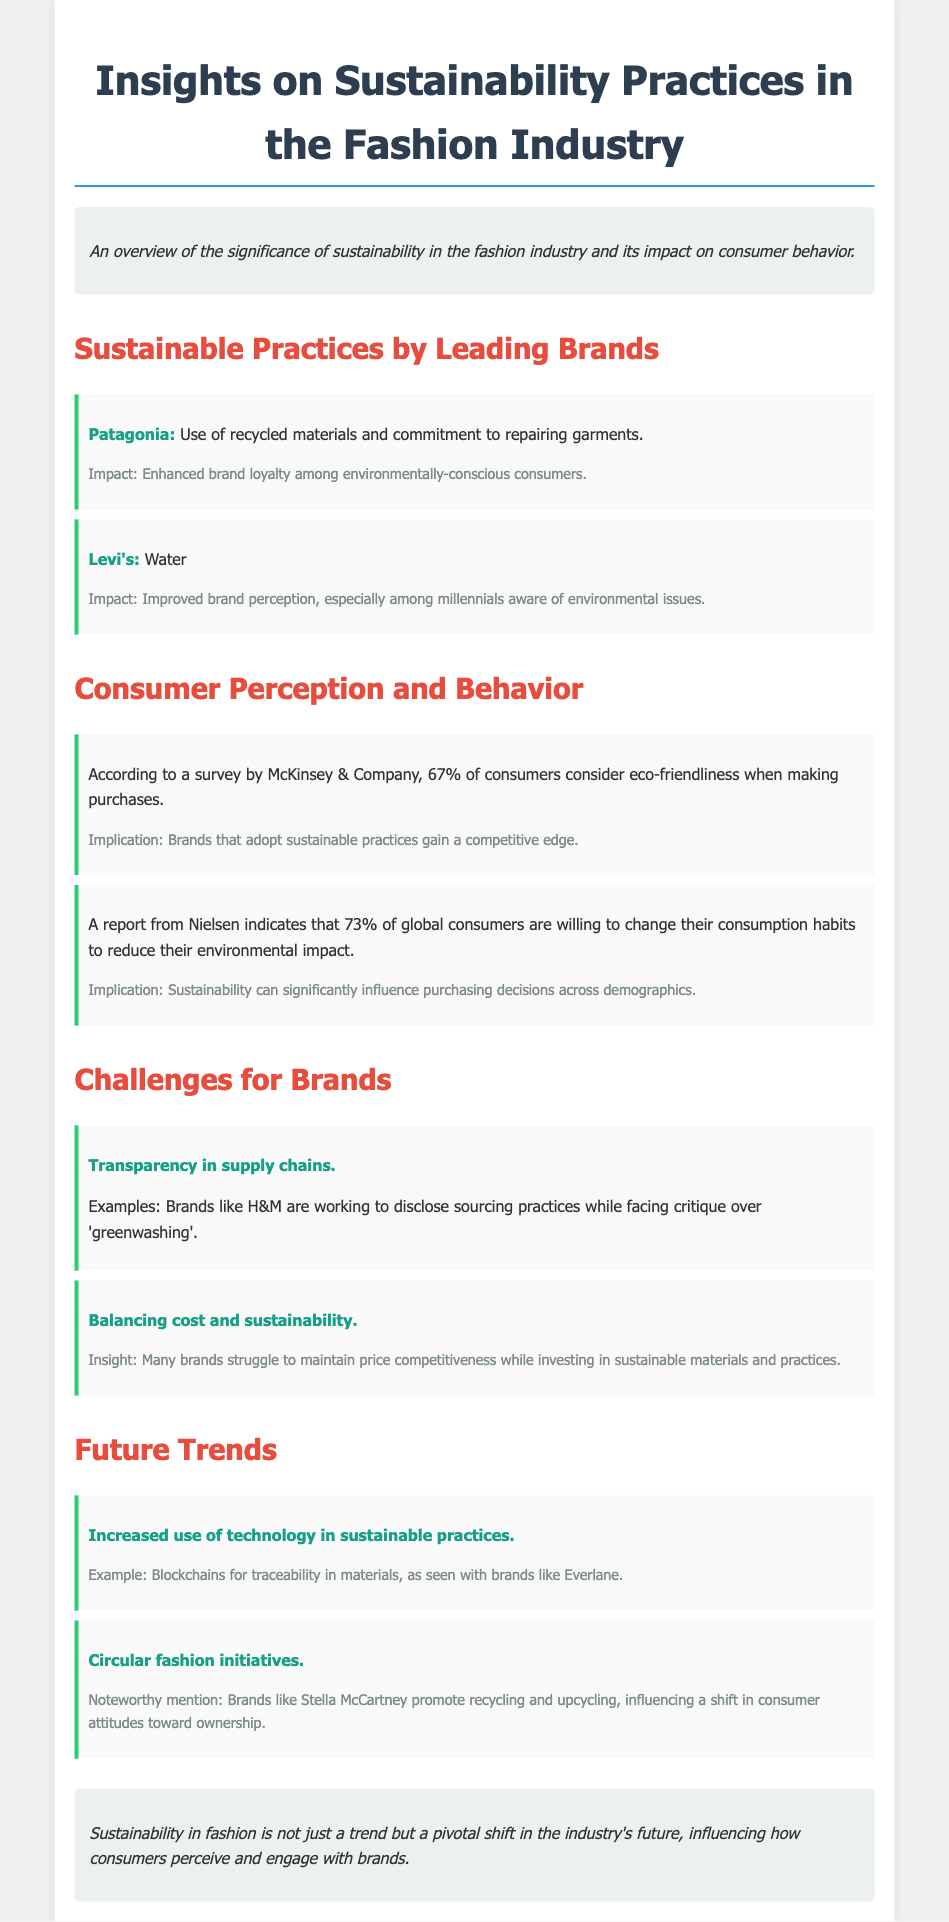What sustainable practice does Patagonia implement? Patagonia uses recycled materials and is committed to repairing garments.
Answer: Recycled materials and repairing garments What percentage of consumers consider eco-friendliness when making purchases? According to a survey by McKinsey & Company, 67% of consumers consider eco-friendliness.
Answer: 67% What challenge do brands like H&M face regarding supply chains? Brands like H&M are working to disclose sourcing practices while facing critique over 'greenwashing'.
Answer: Greenwashing What is the implication of 73% of global consumers being willing to change their consumption habits? This suggests that sustainability can significantly influence purchasing decisions across demographics.
Answer: Significant influence on purchasing decisions What future trend involves the use of blockchains for traceability? Increased use of technology in sustainable practices is a future trend involving blockchains for traceability.
Answer: Technology in sustainable practices Which brand promotes recycling and upcycling in circular fashion initiatives? Brands like Stella McCartney promote recycling and upcycling.
Answer: Stella McCartney 